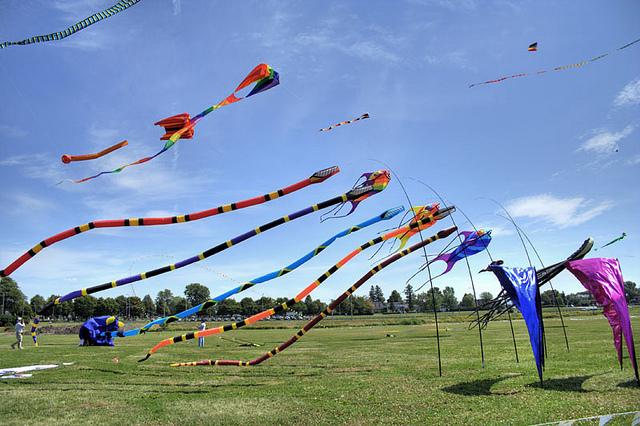How many kites in the sky?
Quick response, please. 13. How many people are in this picture?
Short answer required. 2. Is it windy?
Give a very brief answer. Yes. 